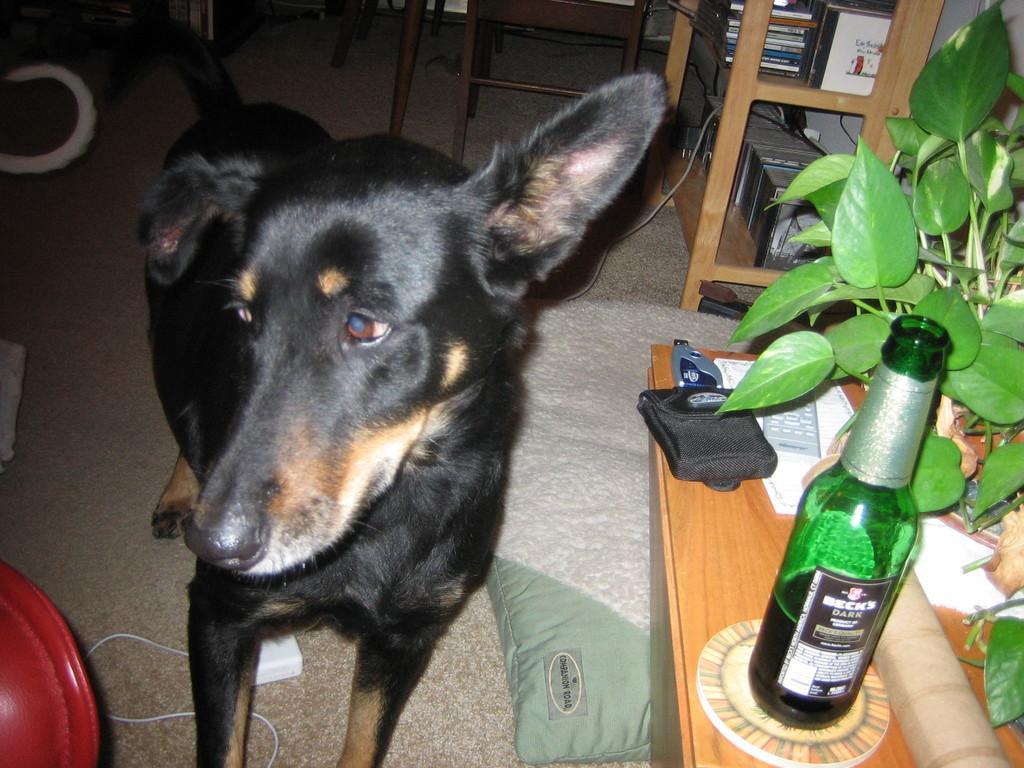How would you summarize this image in a sentence or two? A black dog in standing. Beside the dog there is a pillow and a table. On the table there is a pouch, green bottle and a plants. In the background there is a cupboard with many books. 